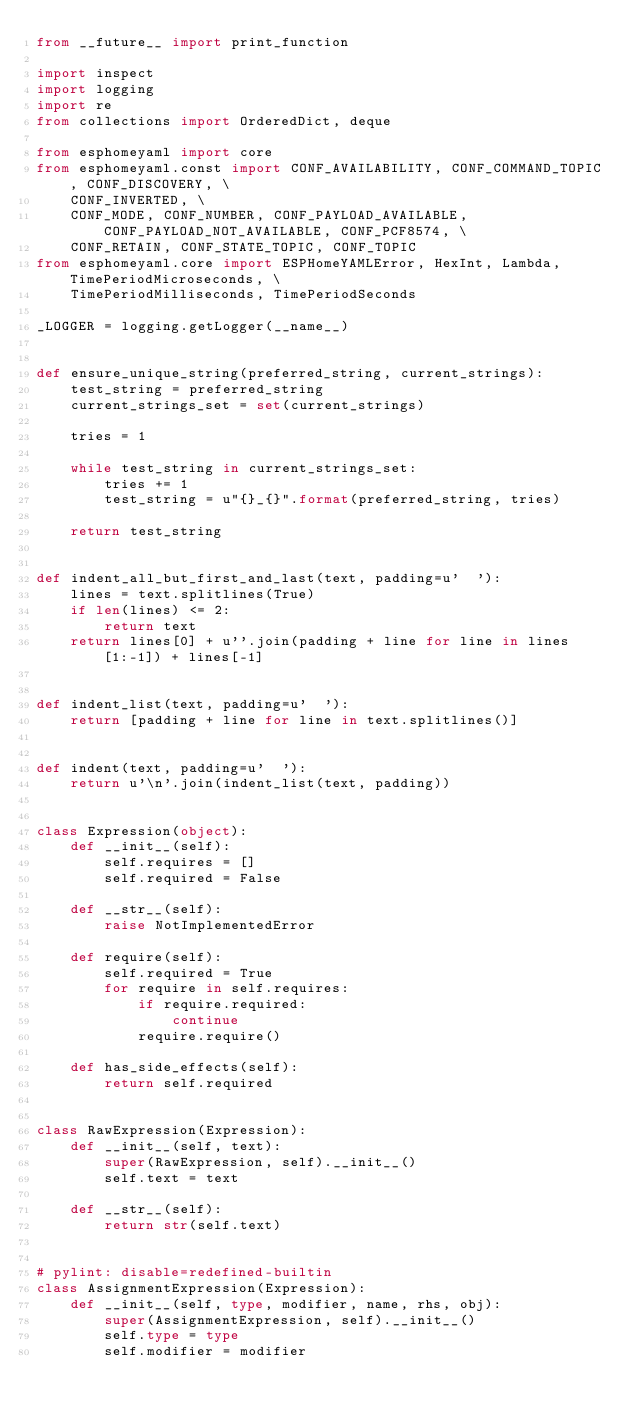<code> <loc_0><loc_0><loc_500><loc_500><_Python_>from __future__ import print_function

import inspect
import logging
import re
from collections import OrderedDict, deque

from esphomeyaml import core
from esphomeyaml.const import CONF_AVAILABILITY, CONF_COMMAND_TOPIC, CONF_DISCOVERY, \
    CONF_INVERTED, \
    CONF_MODE, CONF_NUMBER, CONF_PAYLOAD_AVAILABLE, CONF_PAYLOAD_NOT_AVAILABLE, CONF_PCF8574, \
    CONF_RETAIN, CONF_STATE_TOPIC, CONF_TOPIC
from esphomeyaml.core import ESPHomeYAMLError, HexInt, Lambda, TimePeriodMicroseconds, \
    TimePeriodMilliseconds, TimePeriodSeconds

_LOGGER = logging.getLogger(__name__)


def ensure_unique_string(preferred_string, current_strings):
    test_string = preferred_string
    current_strings_set = set(current_strings)

    tries = 1

    while test_string in current_strings_set:
        tries += 1
        test_string = u"{}_{}".format(preferred_string, tries)

    return test_string


def indent_all_but_first_and_last(text, padding=u'  '):
    lines = text.splitlines(True)
    if len(lines) <= 2:
        return text
    return lines[0] + u''.join(padding + line for line in lines[1:-1]) + lines[-1]


def indent_list(text, padding=u'  '):
    return [padding + line for line in text.splitlines()]


def indent(text, padding=u'  '):
    return u'\n'.join(indent_list(text, padding))


class Expression(object):
    def __init__(self):
        self.requires = []
        self.required = False

    def __str__(self):
        raise NotImplementedError

    def require(self):
        self.required = True
        for require in self.requires:
            if require.required:
                continue
            require.require()

    def has_side_effects(self):
        return self.required


class RawExpression(Expression):
    def __init__(self, text):
        super(RawExpression, self).__init__()
        self.text = text

    def __str__(self):
        return str(self.text)


# pylint: disable=redefined-builtin
class AssignmentExpression(Expression):
    def __init__(self, type, modifier, name, rhs, obj):
        super(AssignmentExpression, self).__init__()
        self.type = type
        self.modifier = modifier</code> 